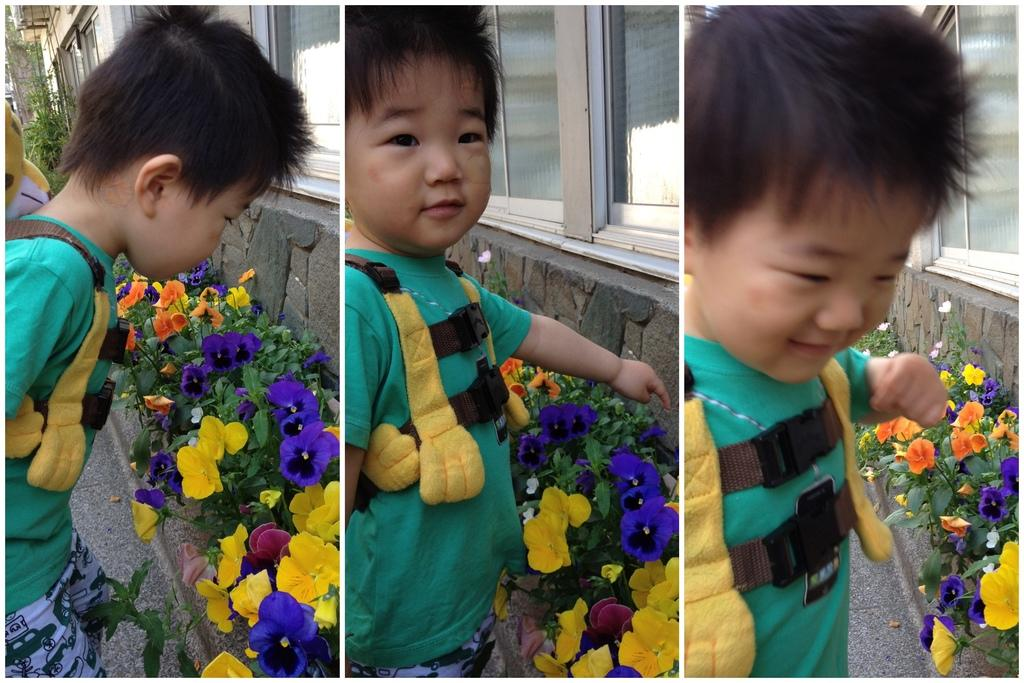What is the main subject of the image? The image contains a collage of three pictures. What can be seen in the first picture of the collage? One picture in the collage shows a kid. What is depicted in the second picture of the collage? Another picture in the collage shows plants. What is the subject of the third picture in the collage? The third picture in the collage shows flowers. What architectural feature is visible in the image? There is a window visible in the image. What type of light bulb can be seen in the image? There is no light bulb present in the image; it contains a collage of three pictures featuring a kid, plants, and flowers, as well as a window. 